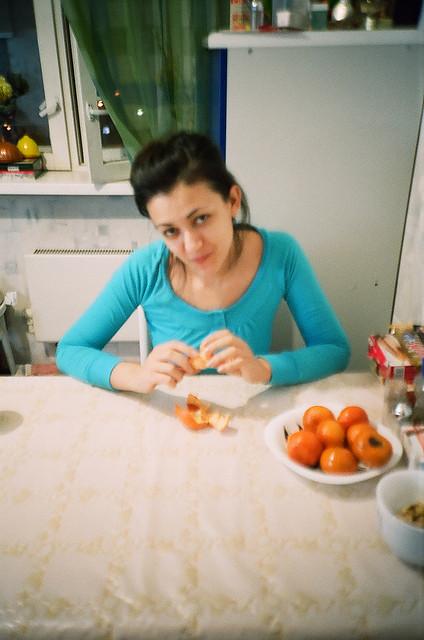What is on the white plate?
Write a very short answer. Oranges. Where is location?
Answer briefly. Kitchen. What vegetable is on the table?
Write a very short answer. Tomato. Is this a restaurant?
Write a very short answer. No. What is on the wall above the food?
Answer briefly. Shelf. Is this a man?
Answer briefly. No. Is the woman celebrating her birthday?
Give a very brief answer. No. Is the window opened or closed?
Be succinct. Open. Is the person wearing a ring?
Write a very short answer. No. What are the white objects in the bowl?
Short answer required. Tomatoes. 